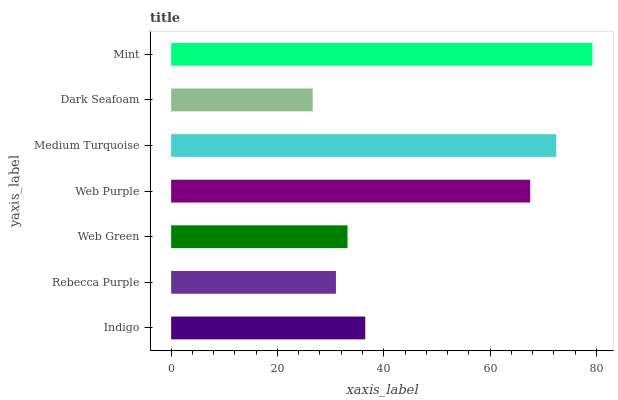Is Dark Seafoam the minimum?
Answer yes or no. Yes. Is Mint the maximum?
Answer yes or no. Yes. Is Rebecca Purple the minimum?
Answer yes or no. No. Is Rebecca Purple the maximum?
Answer yes or no. No. Is Indigo greater than Rebecca Purple?
Answer yes or no. Yes. Is Rebecca Purple less than Indigo?
Answer yes or no. Yes. Is Rebecca Purple greater than Indigo?
Answer yes or no. No. Is Indigo less than Rebecca Purple?
Answer yes or no. No. Is Indigo the high median?
Answer yes or no. Yes. Is Indigo the low median?
Answer yes or no. Yes. Is Rebecca Purple the high median?
Answer yes or no. No. Is Medium Turquoise the low median?
Answer yes or no. No. 